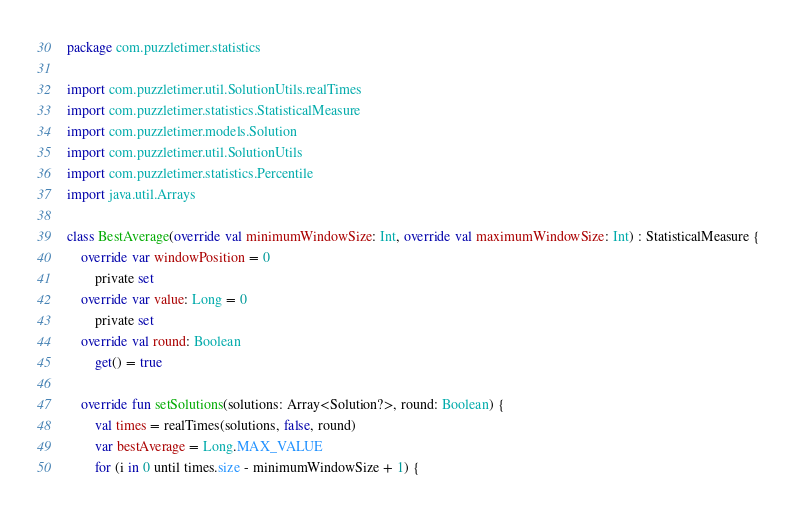<code> <loc_0><loc_0><loc_500><loc_500><_Kotlin_>package com.puzzletimer.statistics

import com.puzzletimer.util.SolutionUtils.realTimes
import com.puzzletimer.statistics.StatisticalMeasure
import com.puzzletimer.models.Solution
import com.puzzletimer.util.SolutionUtils
import com.puzzletimer.statistics.Percentile
import java.util.Arrays

class BestAverage(override val minimumWindowSize: Int, override val maximumWindowSize: Int) : StatisticalMeasure {
    override var windowPosition = 0
        private set
    override var value: Long = 0
        private set
    override val round: Boolean
        get() = true

    override fun setSolutions(solutions: Array<Solution?>, round: Boolean) {
        val times = realTimes(solutions, false, round)
        var bestAverage = Long.MAX_VALUE
        for (i in 0 until times.size - minimumWindowSize + 1) {</code> 